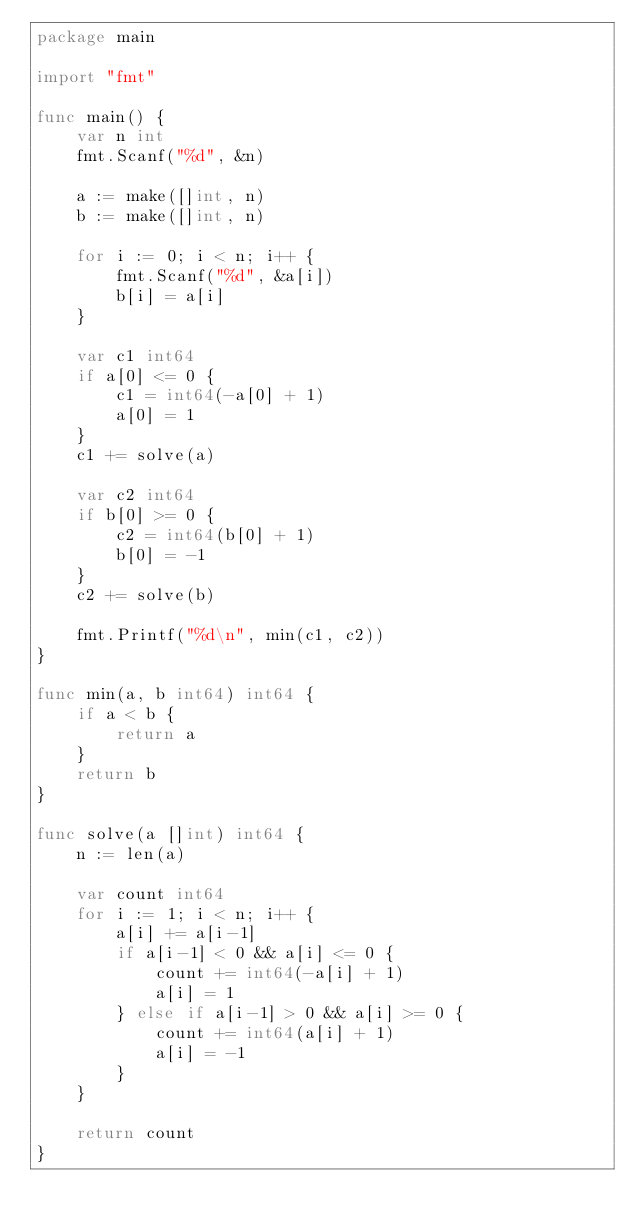Convert code to text. <code><loc_0><loc_0><loc_500><loc_500><_Go_>package main

import "fmt"

func main() {
	var n int
	fmt.Scanf("%d", &n)

	a := make([]int, n)
	b := make([]int, n)

	for i := 0; i < n; i++ {
		fmt.Scanf("%d", &a[i])
		b[i] = a[i]
	}

	var c1 int64
	if a[0] <= 0 {
		c1 = int64(-a[0] + 1)
		a[0] = 1
	}
	c1 += solve(a)

	var c2 int64
	if b[0] >= 0 {
		c2 = int64(b[0] + 1)
		b[0] = -1
	}
	c2 += solve(b)

	fmt.Printf("%d\n", min(c1, c2))
}

func min(a, b int64) int64 {
	if a < b {
		return a
	}
	return b
}

func solve(a []int) int64 {
	n := len(a)

	var count int64
	for i := 1; i < n; i++ {
		a[i] += a[i-1]
		if a[i-1] < 0 && a[i] <= 0 {
			count += int64(-a[i] + 1)
			a[i] = 1
		} else if a[i-1] > 0 && a[i] >= 0 {
			count += int64(a[i] + 1)
			a[i] = -1
		}
	}

	return count
}
</code> 